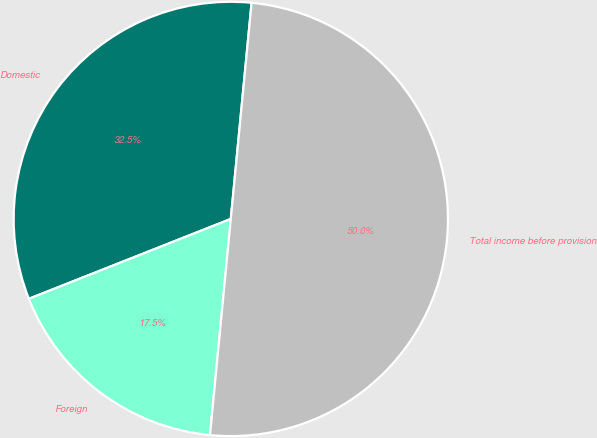Convert chart to OTSL. <chart><loc_0><loc_0><loc_500><loc_500><pie_chart><fcel>Domestic<fcel>Foreign<fcel>Total income before provision<nl><fcel>32.52%<fcel>17.48%<fcel>50.0%<nl></chart> 